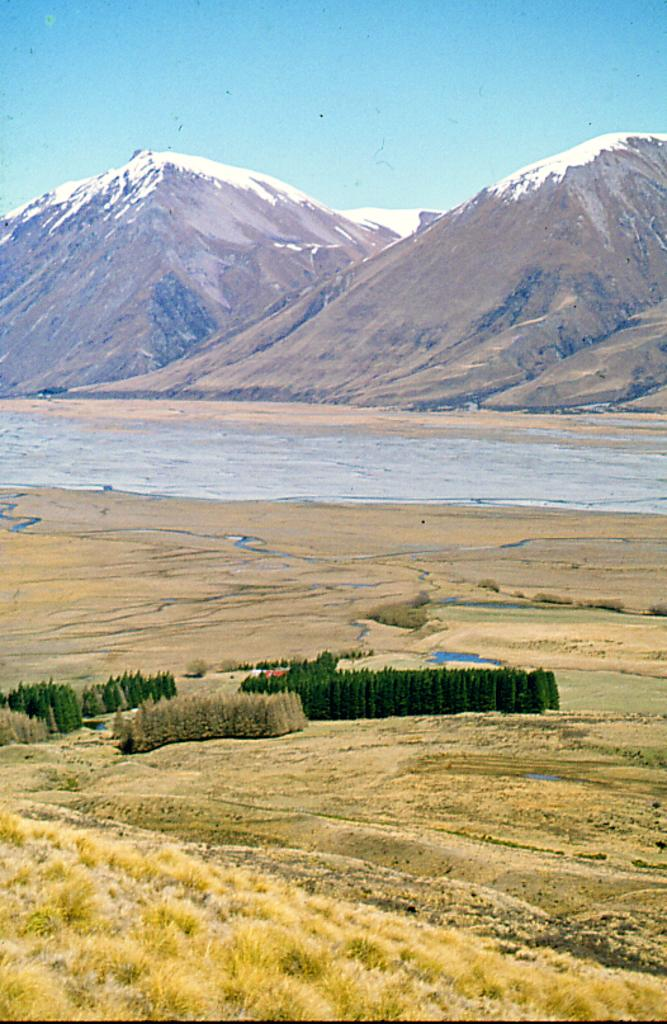What type of vegetation can be seen in the image? There is dry grass in the image. What other natural elements are present in the image? There are trees and water visible in the image. What type of geographical feature can be seen in the image? There are mountains in the image. What is the color of the sky in the image? The sky is blue and visible in the background of the image. Can you tell me where the creature is hiding in the alley in the image? There is no creature or alley present in the image. What type of receipt can be seen on the ground in the image? There is no receipt present in the image. 